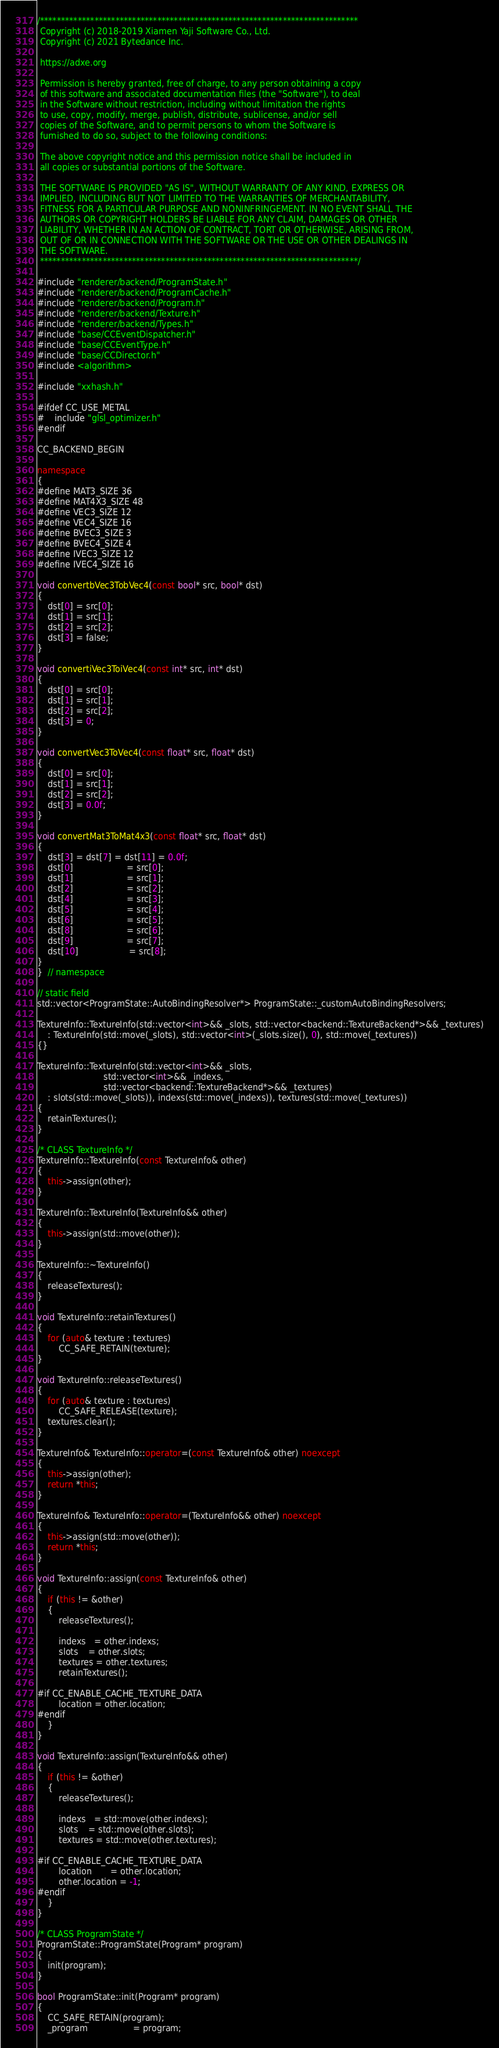<code> <loc_0><loc_0><loc_500><loc_500><_C++_>/****************************************************************************
 Copyright (c) 2018-2019 Xiamen Yaji Software Co., Ltd.
 Copyright (c) 2021 Bytedance Inc.

 https://adxe.org

 Permission is hereby granted, free of charge, to any person obtaining a copy
 of this software and associated documentation files (the "Software"), to deal
 in the Software without restriction, including without limitation the rights
 to use, copy, modify, merge, publish, distribute, sublicense, and/or sell
 copies of the Software, and to permit persons to whom the Software is
 furnished to do so, subject to the following conditions:

 The above copyright notice and this permission notice shall be included in
 all copies or substantial portions of the Software.

 THE SOFTWARE IS PROVIDED "AS IS", WITHOUT WARRANTY OF ANY KIND, EXPRESS OR
 IMPLIED, INCLUDING BUT NOT LIMITED TO THE WARRANTIES OF MERCHANTABILITY,
 FITNESS FOR A PARTICULAR PURPOSE AND NONINFRINGEMENT. IN NO EVENT SHALL THE
 AUTHORS OR COPYRIGHT HOLDERS BE LIABLE FOR ANY CLAIM, DAMAGES OR OTHER
 LIABILITY, WHETHER IN AN ACTION OF CONTRACT, TORT OR OTHERWISE, ARISING FROM,
 OUT OF OR IN CONNECTION WITH THE SOFTWARE OR THE USE OR OTHER DEALINGS IN
 THE SOFTWARE.
 ****************************************************************************/

#include "renderer/backend/ProgramState.h"
#include "renderer/backend/ProgramCache.h"
#include "renderer/backend/Program.h"
#include "renderer/backend/Texture.h"
#include "renderer/backend/Types.h"
#include "base/CCEventDispatcher.h"
#include "base/CCEventType.h"
#include "base/CCDirector.h"
#include <algorithm>

#include "xxhash.h"

#ifdef CC_USE_METAL
#    include "glsl_optimizer.h"
#endif

CC_BACKEND_BEGIN

namespace
{
#define MAT3_SIZE 36
#define MAT4X3_SIZE 48
#define VEC3_SIZE 12
#define VEC4_SIZE 16
#define BVEC3_SIZE 3
#define BVEC4_SIZE 4
#define IVEC3_SIZE 12
#define IVEC4_SIZE 16

void convertbVec3TobVec4(const bool* src, bool* dst)
{
    dst[0] = src[0];
    dst[1] = src[1];
    dst[2] = src[2];
    dst[3] = false;
}

void convertiVec3ToiVec4(const int* src, int* dst)
{
    dst[0] = src[0];
    dst[1] = src[1];
    dst[2] = src[2];
    dst[3] = 0;
}

void convertVec3ToVec4(const float* src, float* dst)
{
    dst[0] = src[0];
    dst[1] = src[1];
    dst[2] = src[2];
    dst[3] = 0.0f;
}

void convertMat3ToMat4x3(const float* src, float* dst)
{
    dst[3] = dst[7] = dst[11] = 0.0f;
    dst[0]                    = src[0];
    dst[1]                    = src[1];
    dst[2]                    = src[2];
    dst[4]                    = src[3];
    dst[5]                    = src[4];
    dst[6]                    = src[5];
    dst[8]                    = src[6];
    dst[9]                    = src[7];
    dst[10]                   = src[8];
}
}  // namespace

// static field
std::vector<ProgramState::AutoBindingResolver*> ProgramState::_customAutoBindingResolvers;

TextureInfo::TextureInfo(std::vector<int>&& _slots, std::vector<backend::TextureBackend*>&& _textures)
    : TextureInfo(std::move(_slots), std::vector<int>(_slots.size(), 0), std::move(_textures))
{}

TextureInfo::TextureInfo(std::vector<int>&& _slots,
                         std::vector<int>&& _indexs,
                         std::vector<backend::TextureBackend*>&& _textures)
    : slots(std::move(_slots)), indexs(std::move(_indexs)), textures(std::move(_textures))
{
    retainTextures();
}

/* CLASS TextureInfo */
TextureInfo::TextureInfo(const TextureInfo& other)
{
    this->assign(other);
}

TextureInfo::TextureInfo(TextureInfo&& other)
{
    this->assign(std::move(other));
}

TextureInfo::~TextureInfo()
{
    releaseTextures();
}

void TextureInfo::retainTextures()
{
    for (auto& texture : textures)
        CC_SAFE_RETAIN(texture);
}

void TextureInfo::releaseTextures()
{
    for (auto& texture : textures)
        CC_SAFE_RELEASE(texture);
    textures.clear();
}

TextureInfo& TextureInfo::operator=(const TextureInfo& other) noexcept
{
    this->assign(other);
    return *this;
}

TextureInfo& TextureInfo::operator=(TextureInfo&& other) noexcept
{
    this->assign(std::move(other));
    return *this;
}

void TextureInfo::assign(const TextureInfo& other)
{
    if (this != &other)
    {
        releaseTextures();

        indexs   = other.indexs;
        slots    = other.slots;
        textures = other.textures;
        retainTextures();

#if CC_ENABLE_CACHE_TEXTURE_DATA
        location = other.location;
#endif
    }
}

void TextureInfo::assign(TextureInfo&& other)
{
    if (this != &other)
    {
        releaseTextures();

        indexs   = std::move(other.indexs);
        slots    = std::move(other.slots);
        textures = std::move(other.textures);

#if CC_ENABLE_CACHE_TEXTURE_DATA
        location       = other.location;
        other.location = -1;
#endif
    }
}

/* CLASS ProgramState */
ProgramState::ProgramState(Program* program)
{
    init(program);
}

bool ProgramState::init(Program* program)
{
    CC_SAFE_RETAIN(program);
    _program                 = program;</code> 